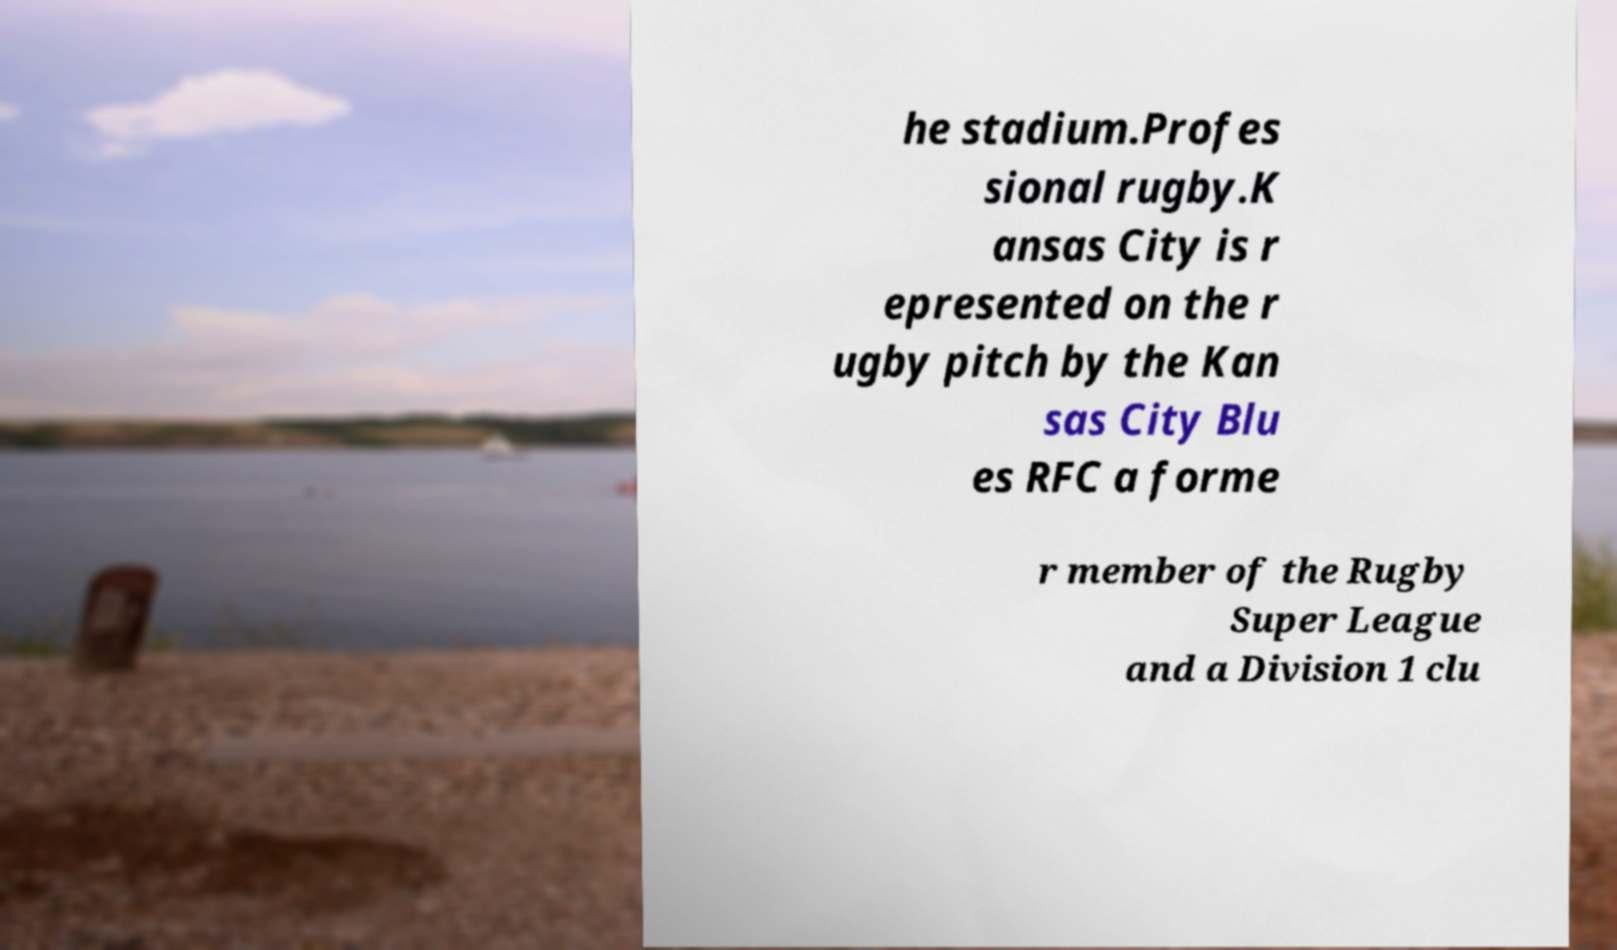Can you accurately transcribe the text from the provided image for me? he stadium.Profes sional rugby.K ansas City is r epresented on the r ugby pitch by the Kan sas City Blu es RFC a forme r member of the Rugby Super League and a Division 1 clu 